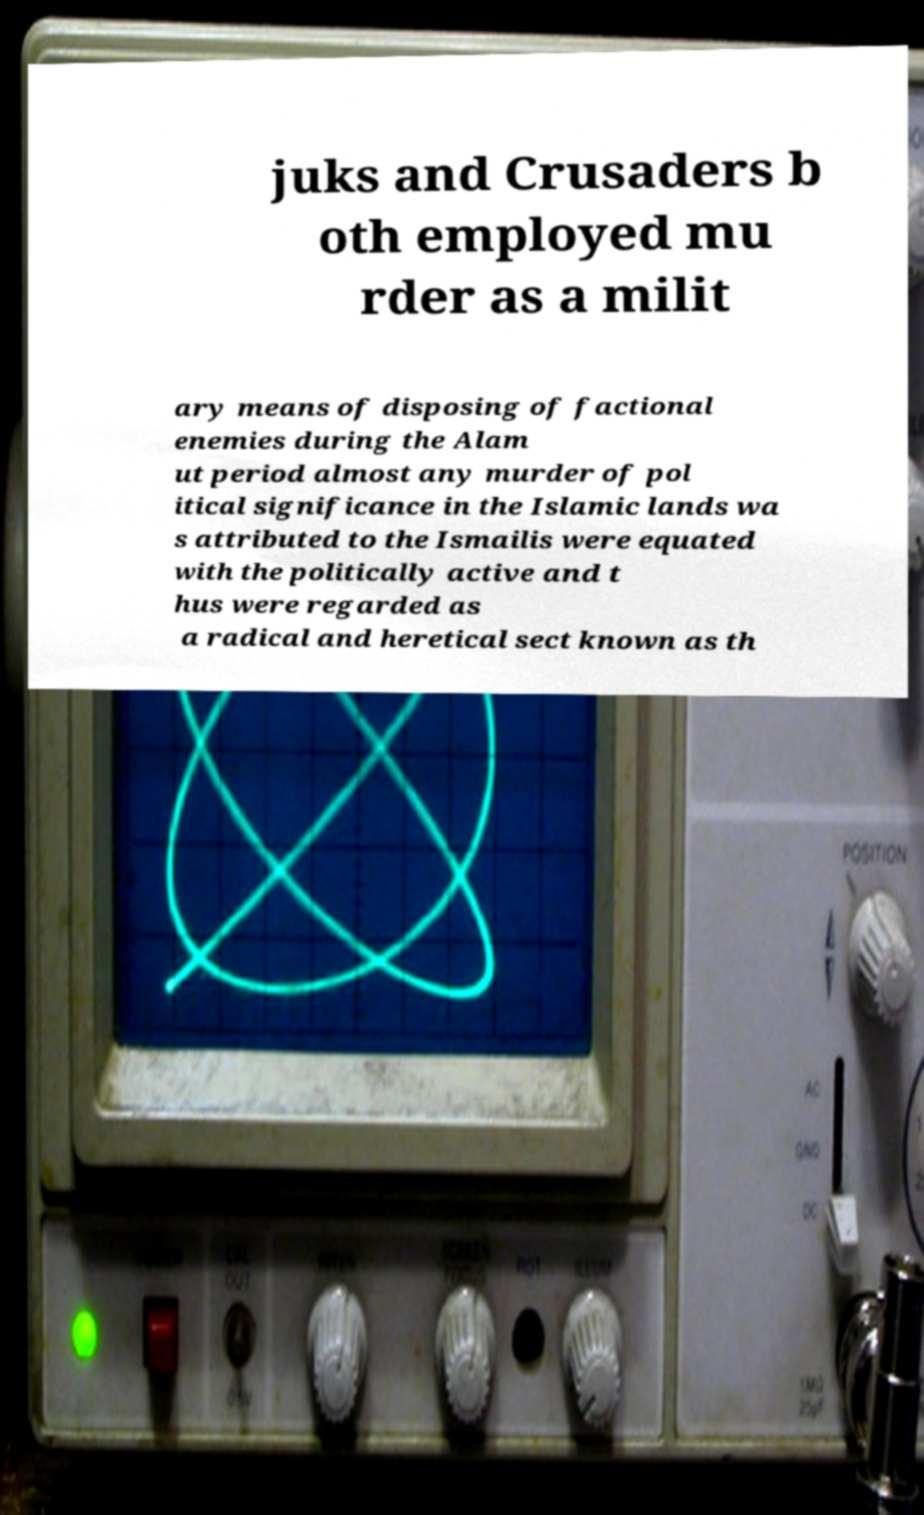Can you accurately transcribe the text from the provided image for me? juks and Crusaders b oth employed mu rder as a milit ary means of disposing of factional enemies during the Alam ut period almost any murder of pol itical significance in the Islamic lands wa s attributed to the Ismailis were equated with the politically active and t hus were regarded as a radical and heretical sect known as th 